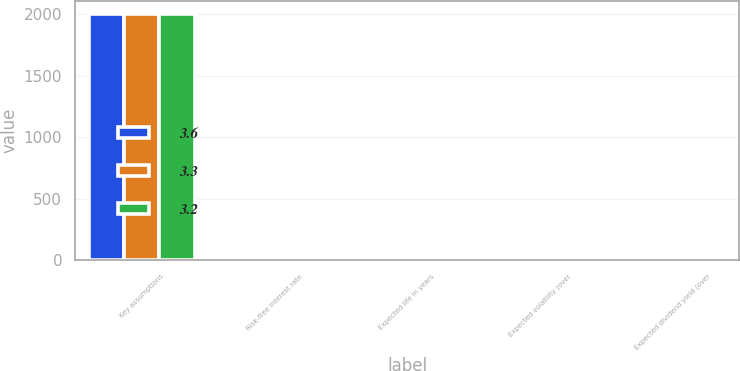<chart> <loc_0><loc_0><loc_500><loc_500><stacked_bar_chart><ecel><fcel>Key assumptions<fcel>Risk-free interest rate<fcel>Expected life in years<fcel>Expected volatility (over<fcel>Expected dividend yield (over<nl><fcel>3.6<fcel>2007<fcel>4.5<fcel>6.7<fcel>24.5<fcel>3.6<nl><fcel>3.3<fcel>2006<fcel>4.4<fcel>6.7<fcel>27.3<fcel>3.2<nl><fcel>3.2<fcel>2005<fcel>4<fcel>6.3<fcel>25.7<fcel>3.3<nl></chart> 